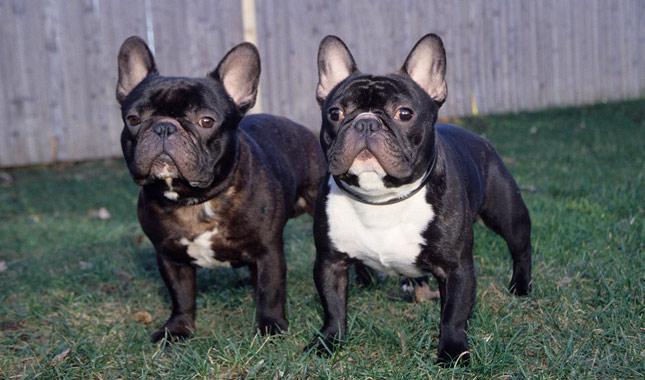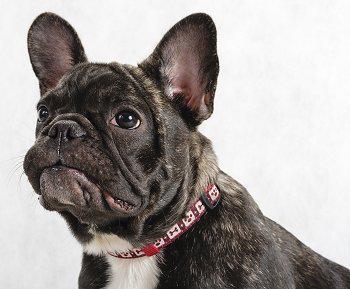The first image is the image on the left, the second image is the image on the right. Evaluate the accuracy of this statement regarding the images: "There is at least one mostly black dog standing on all four legs in the image on the left.". Is it true? Answer yes or no. Yes. 